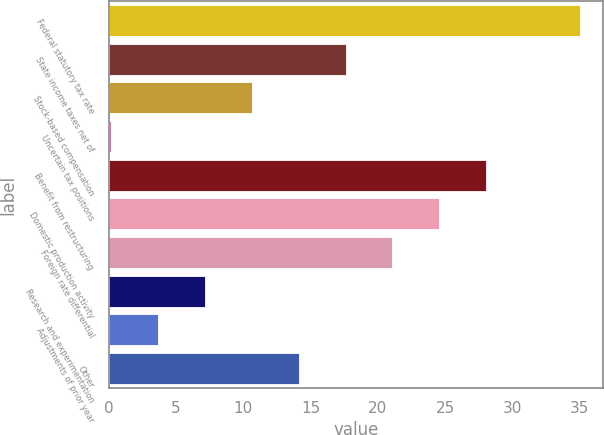Convert chart to OTSL. <chart><loc_0><loc_0><loc_500><loc_500><bar_chart><fcel>Federal statutory tax rate<fcel>State income taxes net of<fcel>Stock-based compensation<fcel>Uncertain tax positions<fcel>Benefit from restructuring<fcel>Domestic production activity<fcel>Foreign rate differential<fcel>Research and experimentation<fcel>Adjustments of prior year<fcel>Other<nl><fcel>35<fcel>17.6<fcel>10.64<fcel>0.2<fcel>28.04<fcel>24.56<fcel>21.08<fcel>7.16<fcel>3.68<fcel>14.12<nl></chart> 